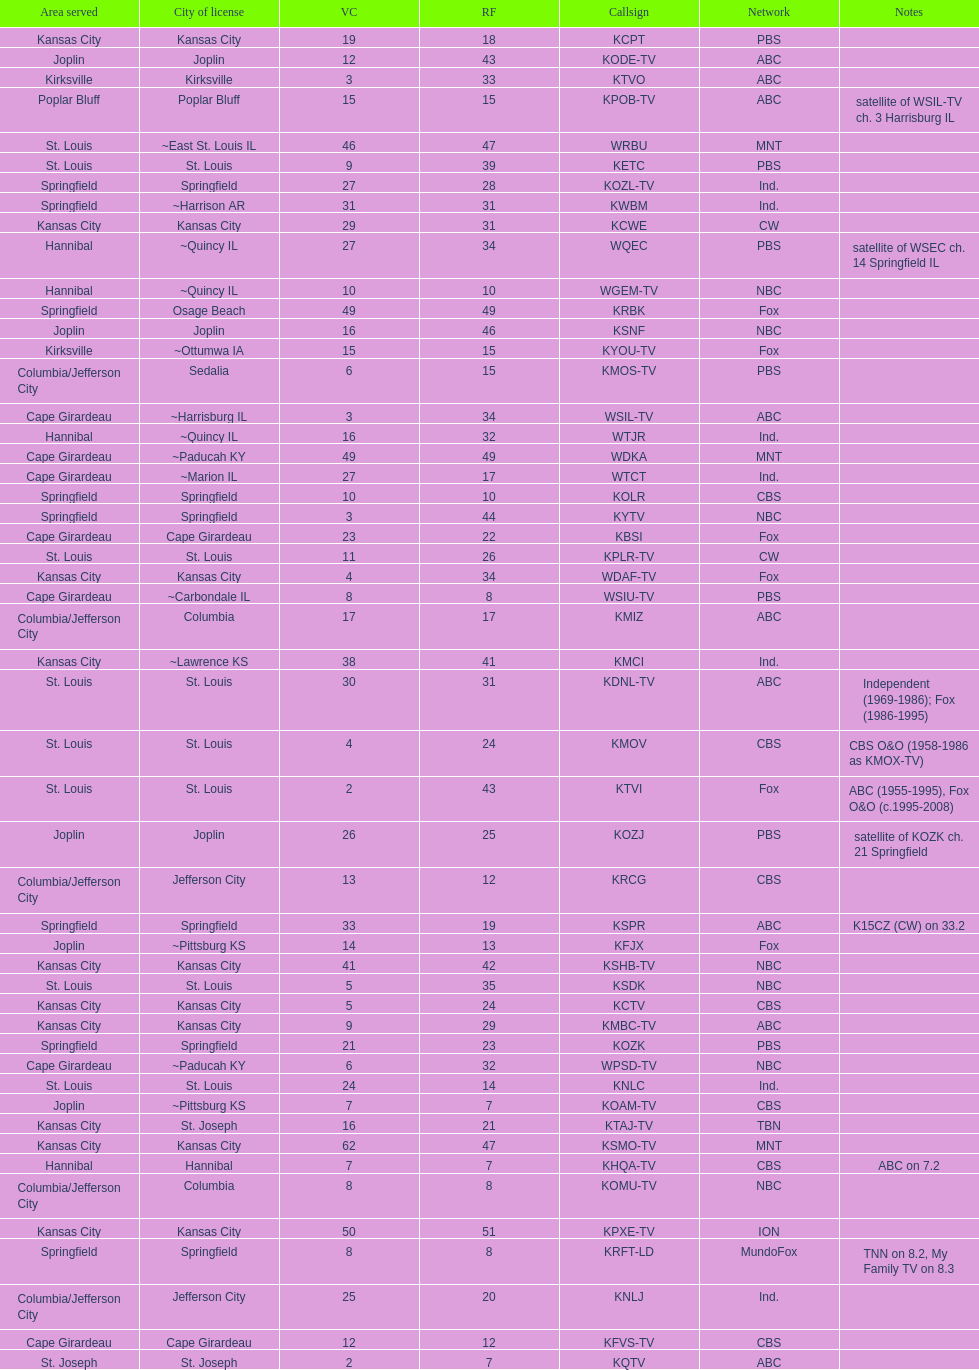Which station is licensed in the same city as koam-tv? KFJX. 